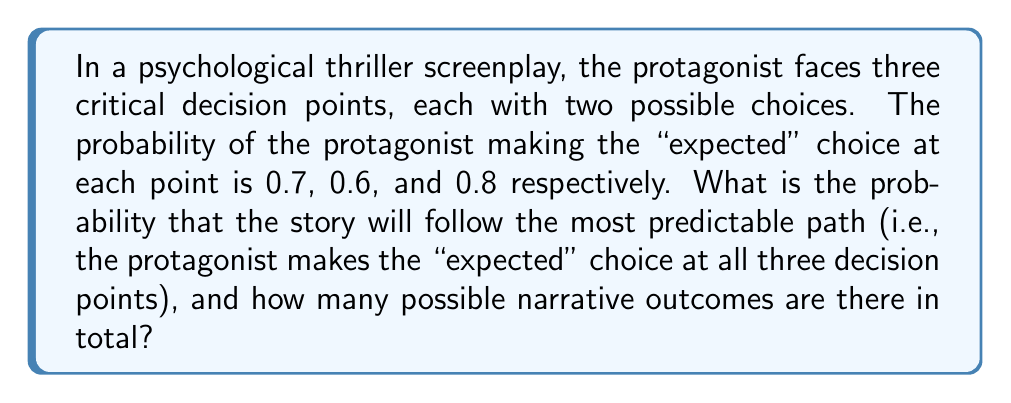Provide a solution to this math problem. To solve this problem, we need to consider two aspects:

1. The probability of the most predictable path
2. The total number of possible narrative outcomes

1. Probability of the most predictable path:

The probability of the protagonist making the "expected" choice at each decision point is given as:
- First decision: 0.7
- Second decision: 0.6
- Third decision: 0.8

To calculate the probability of all three "expected" choices occurring, we multiply these probabilities:

$$P(\text{most predictable path}) = 0.7 \times 0.6 \times 0.8 = 0.336$$

2. Total number of possible narrative outcomes:

At each decision point, there are two possible choices (expected and unexpected). With three decision points, we can use the multiplication principle to determine the total number of possible outcomes:

$$\text{Total outcomes} = 2 \times 2 \times 2 = 2^3 = 8$$

This can be visualized as a decision tree:

[asy]
unitsize(1cm);

pair A = (0,0);
pair B1 = (-3,-2);
pair B2 = (3,-2);
pair C1 = (-4,-4);
pair C2 = (-2,-4);
pair C3 = (2,-4);
pair C4 = (4,-4);
pair D1 = (-4.5,-6);
pair D2 = (-3.5,-6);
pair D3 = (-2.5,-6);
pair D4 = (-1.5,-6);
pair D5 = (1.5,-6);
pair D6 = (2.5,-6);
pair D7 = (3.5,-6);
pair D8 = (4.5,-6);

draw(A--B1--C1--D1);
draw(A--B1--C1--D2);
draw(A--B1--C2--D3);
draw(A--B1--C2--D4);
draw(A--B2--C3--D5);
draw(A--B2--C3--D6);
draw(A--B2--C4--D7);
draw(A--B2--C4--D8);

dot(A);
dot(B1); dot(B2);
dot(C1); dot(C2); dot(C3); dot(C4);
dot(D1); dot(D2); dot(D3); dot(D4); dot(D5); dot(D6); dot(D7); dot(D8);

label("Start", A, N);
label("1st", (B1+B2)/2, N);
label("2nd", (C1+C4)/2, N);
label("3rd", (D1+D8)/2, S);

[/asy]

Each path from the start to an end point represents a unique narrative outcome.
Answer: The probability of the story following the most predictable path is 0.336 or 33.6%, and there are 8 possible narrative outcomes in total. 